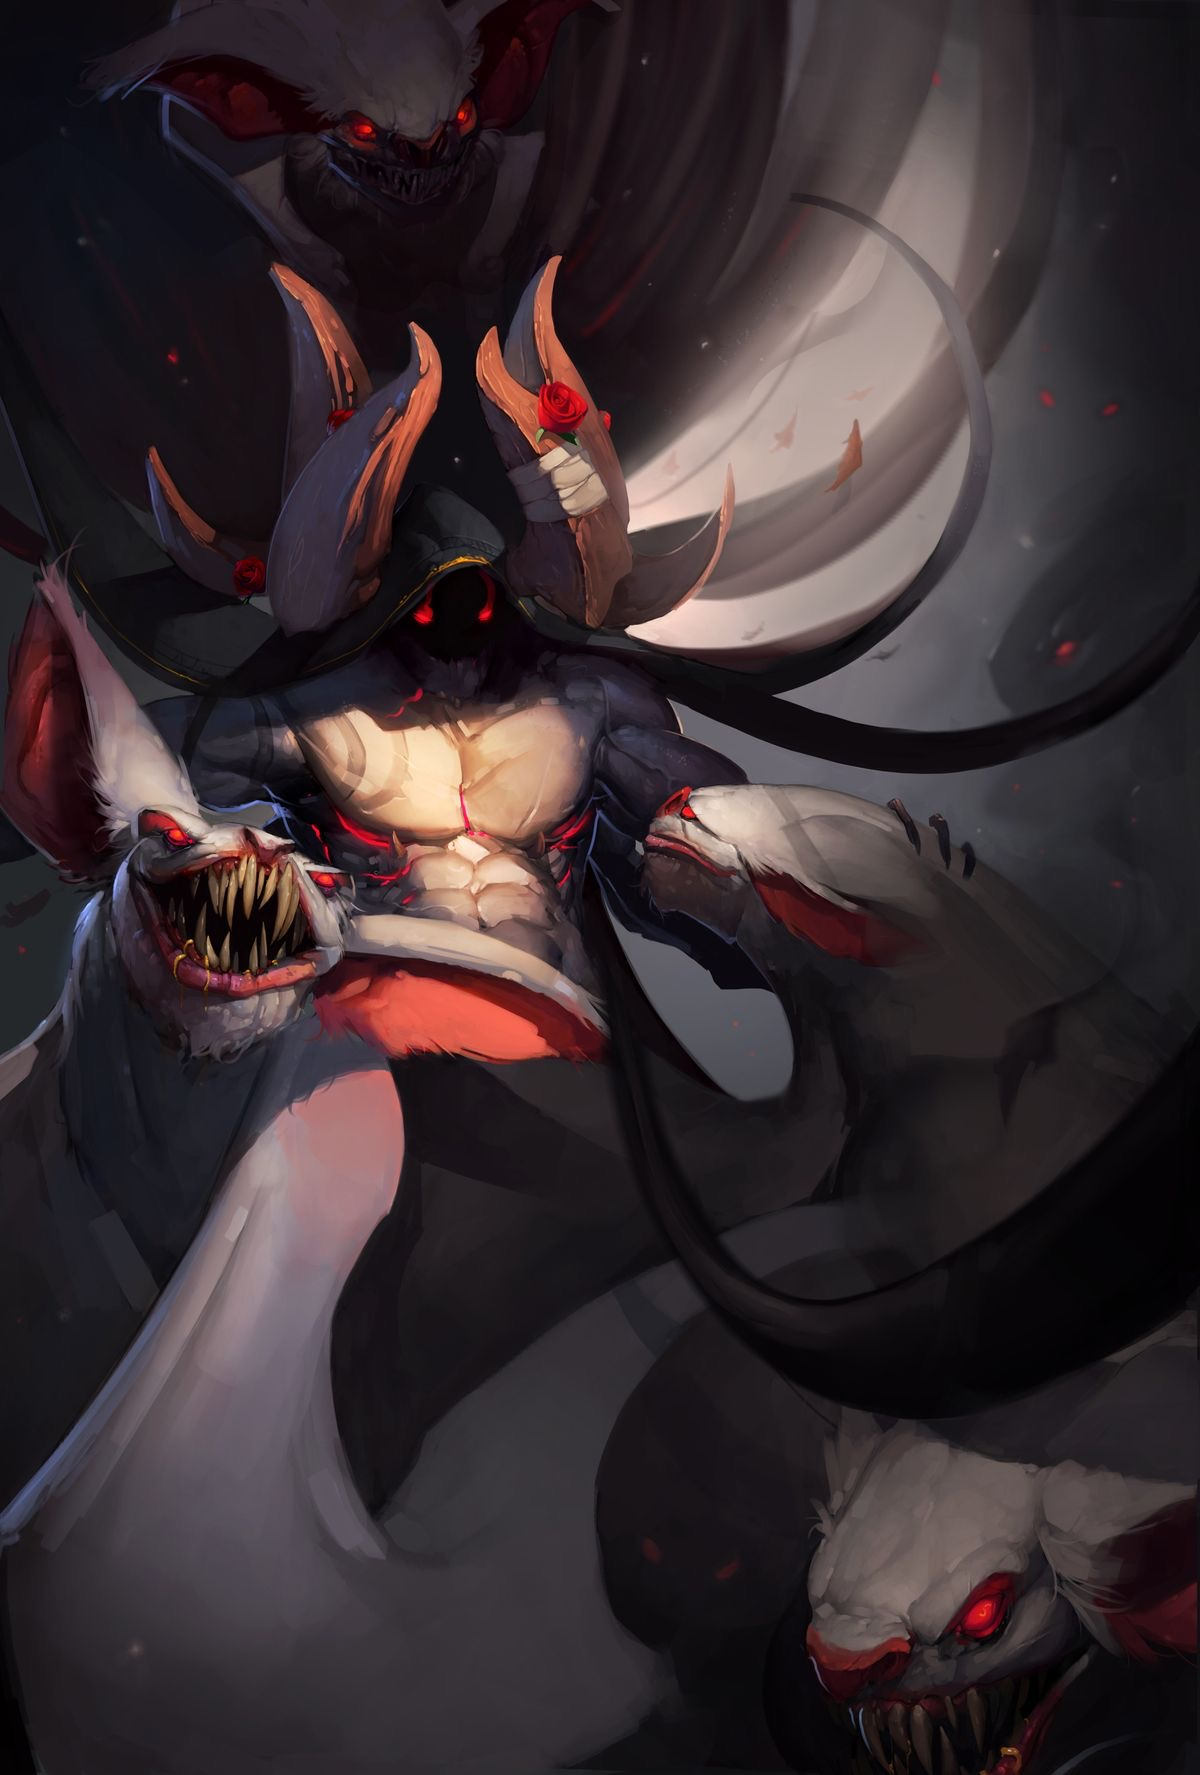describe this image in great detail, including details like the art style, medium, colors, and objects in the image. the word limit is 99  The image depicts a dynamic, dark, and intense representation of a horse. The art style is digital with sharp, flowing lines and intricate detailing. The horse is predominantly black with hints of dark blue and red, exuding a sense of power and ferocity. Its mane and tail are wild, almost flame-like, with red streaks. A jagged white crown, adorned with red accents, hovers above its head. The background is a textured, muted brown, enhancing the dramatic contrast. The overall mood is dark and mysterious, with a gothic, almost mythological feel. describe this image in great detail, including details like the art style, medium, colors, and objects in the image. the word limit is 99  This digital artwork portrays a dark, ethereal horse standing in a misty, swamp-like environment. The horse is black with long, flowing mane and tail, nearly blending into the dim, foggy background. Its eyes are eerily luminous white, adding a mystical aura. The foreground features reflective, murky water and dense, green reeds. The background fades into obscurity with shadowy trees and a thick mist. The overall color palette is dark and muted, dominated by blacks, greens, and grays, creating a haunting, gothic atmosphere. describe this image in great detail, including details like the art style, medium, colors, and objects in the image. the word limit is 99  This digital painting features a majestic white unicorn with a flowing, rainbow-colored mane and tail, standing poised. The unicorn's horn gleams softly, and the ethereal mane and tail create a sense of movement. The background is a stormy sky with ominous, dark clouds forming a shadowy, dragon-like figure, adding tension and contrast. The palette includes soft pastels for the unicorn and dark, foreboding grays for the background. The art style is fantastical, blending realism with dreamy, surreal elements, evoking a sense of wonder and impending danger. describe this image in great detail, including details like the art style, medium, colors, and objects in the image. the word limit is 99  This digital painting portrays a dark, mythical creature resembling a dragon and horse hybrid. The art style is highly detailed and fantastical. The creature has a gray, elongated face with sharp fangs, green glowing eyes, and a forked tongue. Its mane is flowing, teal and dark, blending into the background. The horns are twisted and antler-like, with green, leaf-like accents. The background is a muted, smoky gradient of grays and browns, adding to the creature's mysterious aura. The image is signed "2017.5.12" with an emblem in the bottom right corner. describe this image in great detail, including details like the art style, medium, colors, and objects in the image. the word limit is 99  This digital painting features two centaurs in a misty, enchanted forest. The art style is soft and ethereal, with muted colors. The centaurs have human upper bodies with long, flowing hair and deer-like lower bodies. One centaur stands upright, gazing at the viewer with a calm expression, while the other rears up on its hind legs, reaching for fruit from a tall tree. The background consists of tall, leafy trees and a foggy ambiance, creating a serene, mystical atmosphere. The overall palette includes soft greens, grays, and browns, emphasizing the dreamy quality. describe this image in great detail, including details like the art style, medium, colors, and objects in the image. the word limit is 99  This digital illustration depicts a surreal, tall, bird-like creature with elongated legs and a dark, feathery body. The creature has a long neck, a beak-like mouth, and red eyes. It is interacting with a utility pole, giving the scene an eerie, otherworldly vibe. The background is minimalistic with muted gray tones, featuring faint outlines of additional utility poles, which enhance the creature's towering height. The art style is whimsical and slightly unsettling, with a washed-out, watercolor-like texture that adds to the dreamlike, mysterious atmosphere. describe this image in great detail, including details like the art style, medium, colors, and objects in the image. the word limit is 99  This digital painting showcases a surreal urban scene with a towering, slender, shadowy figure with elongated limbs and red glowing eyes. The creature's dark, wispy form contrasts with the bright, overcast sky. It stands amidst weathered, elevated highways and modern high-rise buildings, suggesting a city in decay. The colors are predominantly cool tones and grays, enhancing the eerie, post-apocalyptic atmosphere. The scene is detailed, capturing the gritty texture of the concrete structures and the ethereal quality of the being, blending realism with a nightmarish fantasy. The image is signed "ARGUNOV STUDIO." describe this image in great detail, including details like the art style, medium, colors, and objects in the image. the word limit is 99  This digital artwork depicts a colossal, tree-like entity with a mushroom cap head standing in a blazing forest. The creature's body is long and segmented, glowing with intense orange and red hues, blending seamlessly with the fiery background. Its head features glowing blue markings, contrasting sharply against the warm colors. The sky is filled with dark, swirling smoke and embers. The art style is surreal and fantastical, with a vivid, almost apocalyptic atmosphere created through a palette dominated by reds, oranges, and blacks. The scene conveys a sense of both wonder and impending doom. describe this image in great detail, including details like the art style, medium, colors, and objects in the image. the word limit is 99  This digital artwork portrays a dark, demonic figure with grotesque features, wielding a large, blood-stained scythe. The creature has a muscular, humanoid body with greenish skin, formidable wings, and chains wrapped around its limbs. Its head is grotesquely framed by a spiked, circular apparatus resembling a halo. The background is a swirling, stormy sky in shades of purples and grays, adding to the ominous atmosphere. The art style is detailed and gothic, with a moody, dark color palette. The scene exudes a sense of horror and menace. describe this image in great detail, including details like the art style, medium, colors, and objects in the image. the word limit is 99  This digital illustration features a menacing, humanoid demon with bat-like wings, seated in a meditative pose. The figure has an elongated, horned head and skeletal, clawed hands. It holds a glowing, rune-inscribed orb in its right hand, emanating bright light. The creature's torso is exposed, revealing sinewy, red musculature and rib-like structures. The background consists of swirling, dark purple and blue clouds with a large, glowing moon, enhancing the ominous atmosphere. The art style is highly detailed and dynamic, with a dark, mystical color palette emphasizing the supernatural theme. describe this image in great detail, including details like the art style, medium, colors, and objects in the image. the word limit is 99  This digital artwork depicts a powerful, winged humanoid figure standing in a desolate, sandy landscape. The figure's muscular body is covered in a smooth, dark, almost liquid-like material that drips from its head and wings, which are expansive and feathered. The head is featureless, adding to the eerie, alien appearance. The color palette is dominated by dark blues and grays, contrasting sharply with the lighter, beige tones of the sandy ground and the pale, cloudy sky. The art style is realistic yet fantastical, capturing a sense of otherworldly strength and mystery. The image is signed "NK." describe this image in great detail, including details like the art style, medium, colors, and objects in the image. the word limit is 99  This digital painting features a sinister, angelic figure with large, fiery orange wings. The figure has a smooth, metallic gray body, crouched in an aggressive stance. A glowing, yellow halo hovers above its head, contrasting with its dark, hollow eyes that emit a faint red glow. The background is a gradient of dark blues and reds, adding depth and intensity to the scene. The art style is dynamic and expressive, with bold brush strokes and vivid colors, creating a dramatic and otherworldly atmosphere. The overall mood is intense and foreboding. describe this image in great detail, including details like the art style, medium, colors, and objects in the image. the word limit is 99  This digital painting features a menacing, bird-like creature with humanoid traits. The creature has dark, feathered wings, a sharp beak, and glowing red eyes. Its body is muscular and covered in dark, jagged feathers. It wears a tattered, greenish cloth around its waist, adorned with small skulls. The creature's talons are extended menacingly, and it appears to be in mid-flight. The background is a muted, cloudy gray, enhancing the eerie, dynamic atmosphere. The art style is detailed and expressive, with a dark, ominous color palette emphasizing the creature's fearsome nature. describe this image in great detail, including details like the art style, medium, colors, and objects in the image. the word limit is 99  This digital painting features a terrifying, multi-headed demon. The central figure has a muscular, humanoid form with three heads: one central demonic face with glowing red eyes and a menacing grin, flanked by two snarling beast heads. The demon has large, curved horns and a dark halo emitting a red glow. It holds a dark orb radiating red energy in one clawed hand. The background is a stormy mix of reds and purples, adding to the chaotic atmosphere. The art style is highly detailed and dynamic, with a dark, ominous color palette emphasizing the creature's fearsome nature. describe this image in great detail, including details like the art style, medium, colors, and objects in the image. the word limit is 99  This digital painting depicts a dark, hooded figure with a muscular, humanoid torso and multiple bat-like heads with red eyes and sharp teeth. The central figure has large, wooden antler-like horns, adorned with red roses, adding a contrasting touch of beauty. Its face is shadowed, with glowing red eyes peering from the darkness. The background is a swirling, smoky gray, creating an ominous atmosphere. The art style is vividly detailed and dynamic, with a dark, moody color palette dominated by blacks, reds, and grays, enhancing the sinister, otherworldly theme. 